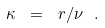<formula> <loc_0><loc_0><loc_500><loc_500>\kappa \ = \ r / \nu \ .</formula> 